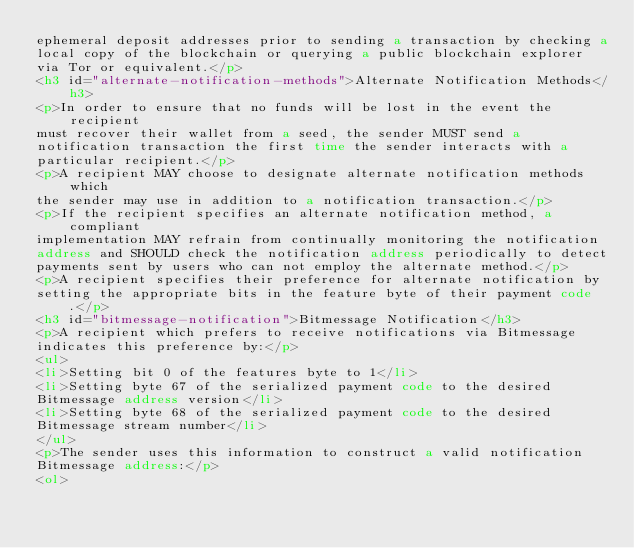<code> <loc_0><loc_0><loc_500><loc_500><_HTML_>ephemeral deposit addresses prior to sending a transaction by checking a
local copy of the blockchain or querying a public blockchain explorer
via Tor or equivalent.</p>
<h3 id="alternate-notification-methods">Alternate Notification Methods</h3>
<p>In order to ensure that no funds will be lost in the event the recipient
must recover their wallet from a seed, the sender MUST send a
notification transaction the first time the sender interacts with a
particular recipient.</p>
<p>A recipient MAY choose to designate alternate notification methods which
the sender may use in addition to a notification transaction.</p>
<p>If the recipient specifies an alternate notification method, a compliant
implementation MAY refrain from continually monitoring the notification
address and SHOULD check the notification address periodically to detect
payments sent by users who can not employ the alternate method.</p>
<p>A recipient specifies their preference for alternate notification by
setting the appropriate bits in the feature byte of their payment code.</p>
<h3 id="bitmessage-notification">Bitmessage Notification</h3>
<p>A recipient which prefers to receive notifications via Bitmessage
indicates this preference by:</p>
<ul>
<li>Setting bit 0 of the features byte to 1</li>
<li>Setting byte 67 of the serialized payment code to the desired
Bitmessage address version</li>
<li>Setting byte 68 of the serialized payment code to the desired
Bitmessage stream number</li>
</ul>
<p>The sender uses this information to construct a valid notification
Bitmessage address:</p>
<ol></code> 